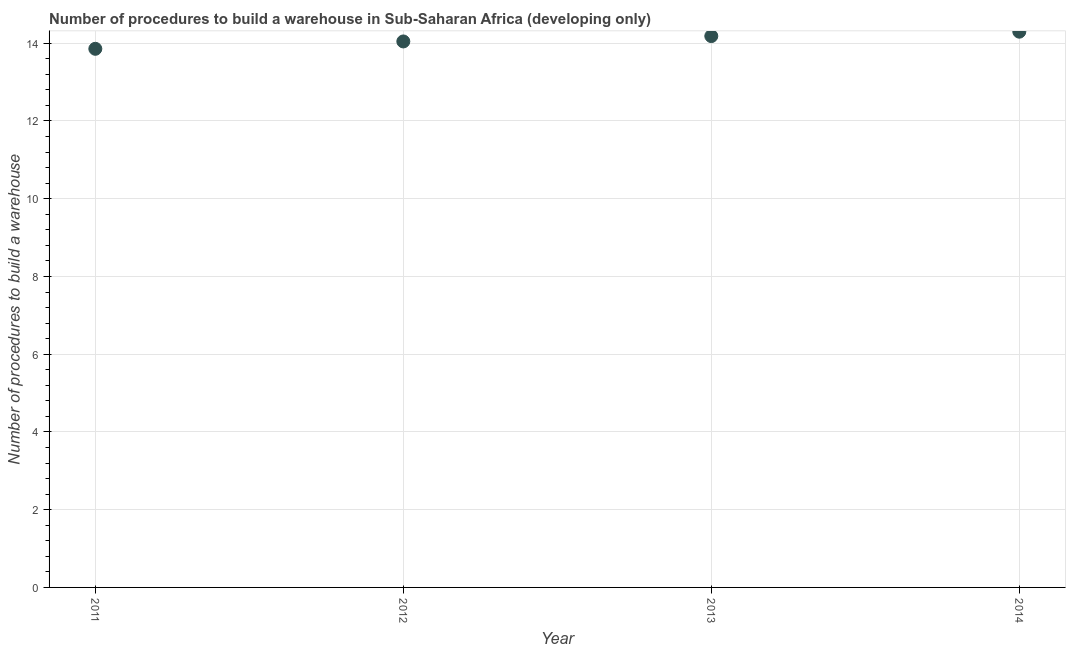What is the number of procedures to build a warehouse in 2014?
Keep it short and to the point. 14.3. Across all years, what is the maximum number of procedures to build a warehouse?
Keep it short and to the point. 14.3. Across all years, what is the minimum number of procedures to build a warehouse?
Keep it short and to the point. 13.86. What is the sum of the number of procedures to build a warehouse?
Give a very brief answer. 56.39. What is the difference between the number of procedures to build a warehouse in 2011 and 2014?
Make the answer very short. -0.44. What is the average number of procedures to build a warehouse per year?
Your answer should be very brief. 14.1. What is the median number of procedures to build a warehouse?
Provide a short and direct response. 14.12. In how many years, is the number of procedures to build a warehouse greater than 6.8 ?
Provide a short and direct response. 4. Do a majority of the years between 2011 and 2013 (inclusive) have number of procedures to build a warehouse greater than 13.2 ?
Ensure brevity in your answer.  Yes. What is the ratio of the number of procedures to build a warehouse in 2011 to that in 2012?
Ensure brevity in your answer.  0.99. Is the difference between the number of procedures to build a warehouse in 2012 and 2013 greater than the difference between any two years?
Your response must be concise. No. What is the difference between the highest and the second highest number of procedures to build a warehouse?
Your answer should be very brief. 0.11. What is the difference between the highest and the lowest number of procedures to build a warehouse?
Your answer should be very brief. 0.44. How many dotlines are there?
Your answer should be compact. 1. What is the difference between two consecutive major ticks on the Y-axis?
Offer a terse response. 2. Are the values on the major ticks of Y-axis written in scientific E-notation?
Provide a short and direct response. No. Does the graph contain any zero values?
Ensure brevity in your answer.  No. Does the graph contain grids?
Ensure brevity in your answer.  Yes. What is the title of the graph?
Provide a succinct answer. Number of procedures to build a warehouse in Sub-Saharan Africa (developing only). What is the label or title of the X-axis?
Offer a terse response. Year. What is the label or title of the Y-axis?
Your answer should be compact. Number of procedures to build a warehouse. What is the Number of procedures to build a warehouse in 2011?
Keep it short and to the point. 13.86. What is the Number of procedures to build a warehouse in 2012?
Your answer should be compact. 14.05. What is the Number of procedures to build a warehouse in 2013?
Your answer should be very brief. 14.18. What is the Number of procedures to build a warehouse in 2014?
Your response must be concise. 14.3. What is the difference between the Number of procedures to build a warehouse in 2011 and 2012?
Your response must be concise. -0.19. What is the difference between the Number of procedures to build a warehouse in 2011 and 2013?
Offer a very short reply. -0.33. What is the difference between the Number of procedures to build a warehouse in 2011 and 2014?
Give a very brief answer. -0.44. What is the difference between the Number of procedures to build a warehouse in 2012 and 2013?
Keep it short and to the point. -0.14. What is the difference between the Number of procedures to build a warehouse in 2012 and 2014?
Your answer should be compact. -0.25. What is the difference between the Number of procedures to build a warehouse in 2013 and 2014?
Your answer should be compact. -0.11. What is the ratio of the Number of procedures to build a warehouse in 2011 to that in 2012?
Offer a terse response. 0.99. What is the ratio of the Number of procedures to build a warehouse in 2011 to that in 2014?
Give a very brief answer. 0.97. What is the ratio of the Number of procedures to build a warehouse in 2012 to that in 2014?
Offer a very short reply. 0.98. What is the ratio of the Number of procedures to build a warehouse in 2013 to that in 2014?
Offer a terse response. 0.99. 